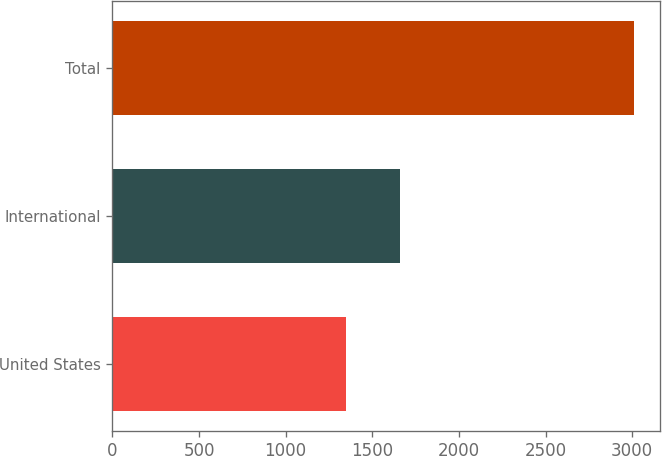Convert chart to OTSL. <chart><loc_0><loc_0><loc_500><loc_500><bar_chart><fcel>United States<fcel>International<fcel>Total<nl><fcel>1349.9<fcel>1660.9<fcel>3010.8<nl></chart> 